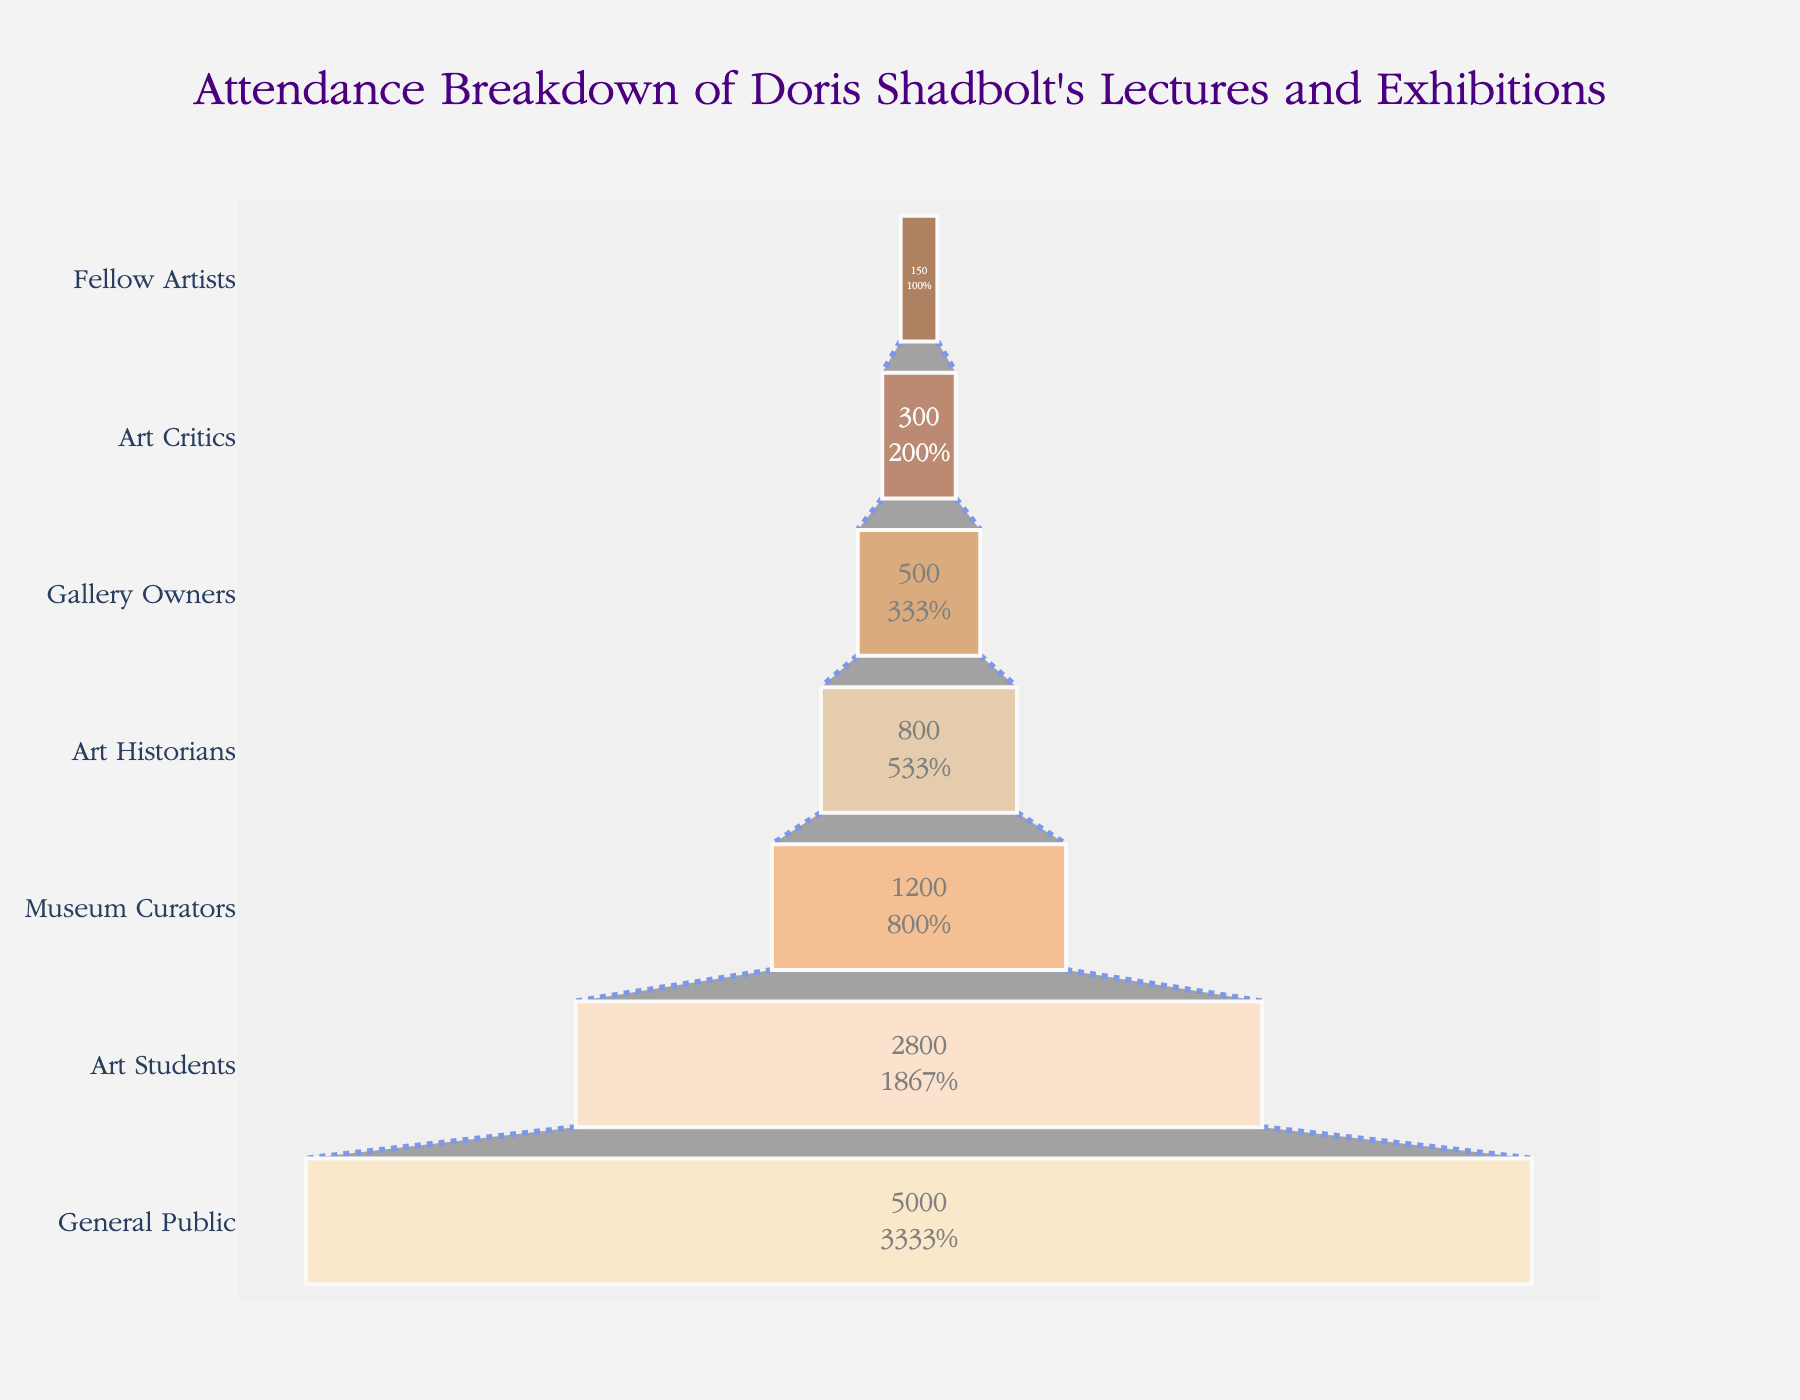What's the title of the figure? The title is displayed prominently at the top of the chart. It's written in a clear, large font for easy reading.
Answer: Attendance Breakdown of Doris Shadbolt's Lectures and Exhibitions How many total categories of attendees are there? Count the number of distinct categories listed along the y-axis of the funnel chart. There are seven categories in total.
Answer: 7 Which group has the highest number of attendees? Identify the top section of the funnel chart, which shows the group with the highest number of attendees, labeled as "General Public."
Answer: General Public What percentage of total attendees are Art Students? Look at the section for Art Students in the funnel chart, which shows both the value and the percentage. The value is 2800, and the percentage represents their proportion of the total attendees.
Answer: 28% What's the difference in attendees between Museum Curators and Art Historians? Subtract the number of attendees in the Art Historians category (800) from the number in the Museum Curators category (1200). 1200 - 800 = 400.
Answer: 400 Which group has the fewest attendees? Identify the bottom section of the funnel chart, which shows the group with the fewest attendees, labeled as "Fellow Artists."
Answer: Fellow Artists How many attendees are there in total from the categories listed? Sum the values from each category together: 5000 + 2800 + 1200 + 800 + 500 + 300 + 150 to get the total.
Answer: 10750 What is the color of the section representing Art Critics? Find the color corresponding to the Art Critics section in the funnel chart, which is "#FFDAB9" or a light peach color.
Answer: Light peach Which group falls between Museum Curators and Gallery Owners in terms of attendance? Look at the positioning within the funnel chart to identify the category that lies between Museum Curators (1200) and Gallery Owners (500). The group is Art Historians (800).
Answer: Art Historians How does the number of attendees for General Public compare to that of Art Students? Compare the values of the two groups: General Public has 5000 attendees and Art Students have 2800. General Public has more attendees.
Answer: General Public has more 